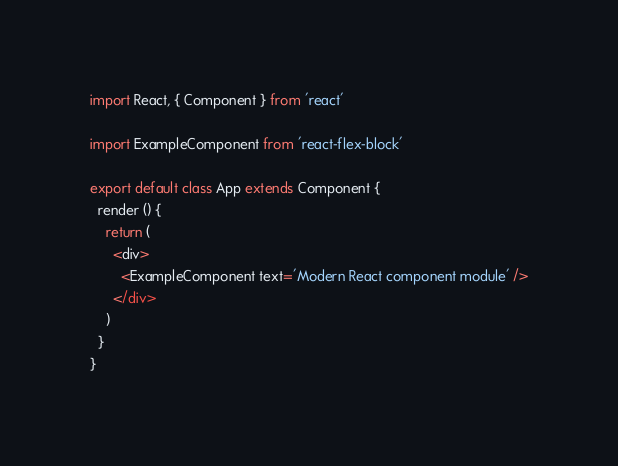Convert code to text. <code><loc_0><loc_0><loc_500><loc_500><_JavaScript_>import React, { Component } from 'react'

import ExampleComponent from 'react-flex-block'

export default class App extends Component {
  render () {
    return (
      <div>
        <ExampleComponent text='Modern React component module' />
      </div>
    )
  }
}
</code> 